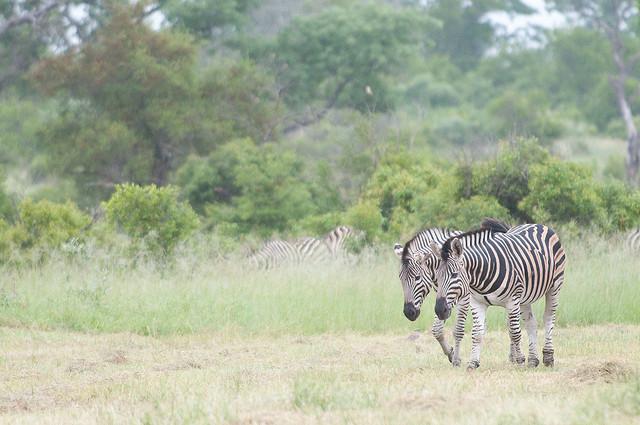How many zebras can you see?
Give a very brief answer. 4. How many zebras are there?
Give a very brief answer. 2. How many people are wearing glassea?
Give a very brief answer. 0. 